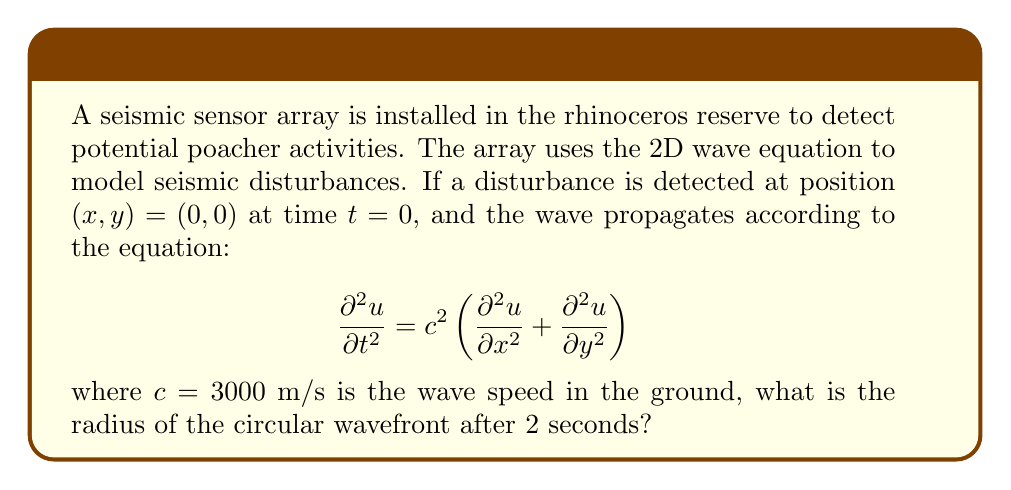Can you solve this math problem? To solve this problem, we'll follow these steps:

1) The 2D wave equation given describes a circular wavefront expanding from the point of origin $(0,0)$.

2) In a homogeneous medium, the wavefront expands uniformly in all directions, forming a circle whose radius increases with time.

3) The radius of this circular wavefront at any time $t$ is given by the simple relation:

   $$r = ct$$

   where $r$ is the radius, $c$ is the wave speed, and $t$ is the time elapsed.

4) We are given:
   - Wave speed $c = 3000$ m/s
   - Time elapsed $t = 2$ s

5) Substituting these values into the equation:

   $$r = (3000 \text{ m/s})(2 \text{ s}) = 6000 \text{ m}$$

6) Therefore, after 2 seconds, the circular wavefront will have a radius of 6000 meters.

This radius represents the distance from the point of origin $(0,0)$ to the leading edge of the seismic disturbance in any direction.
Answer: 6000 m 